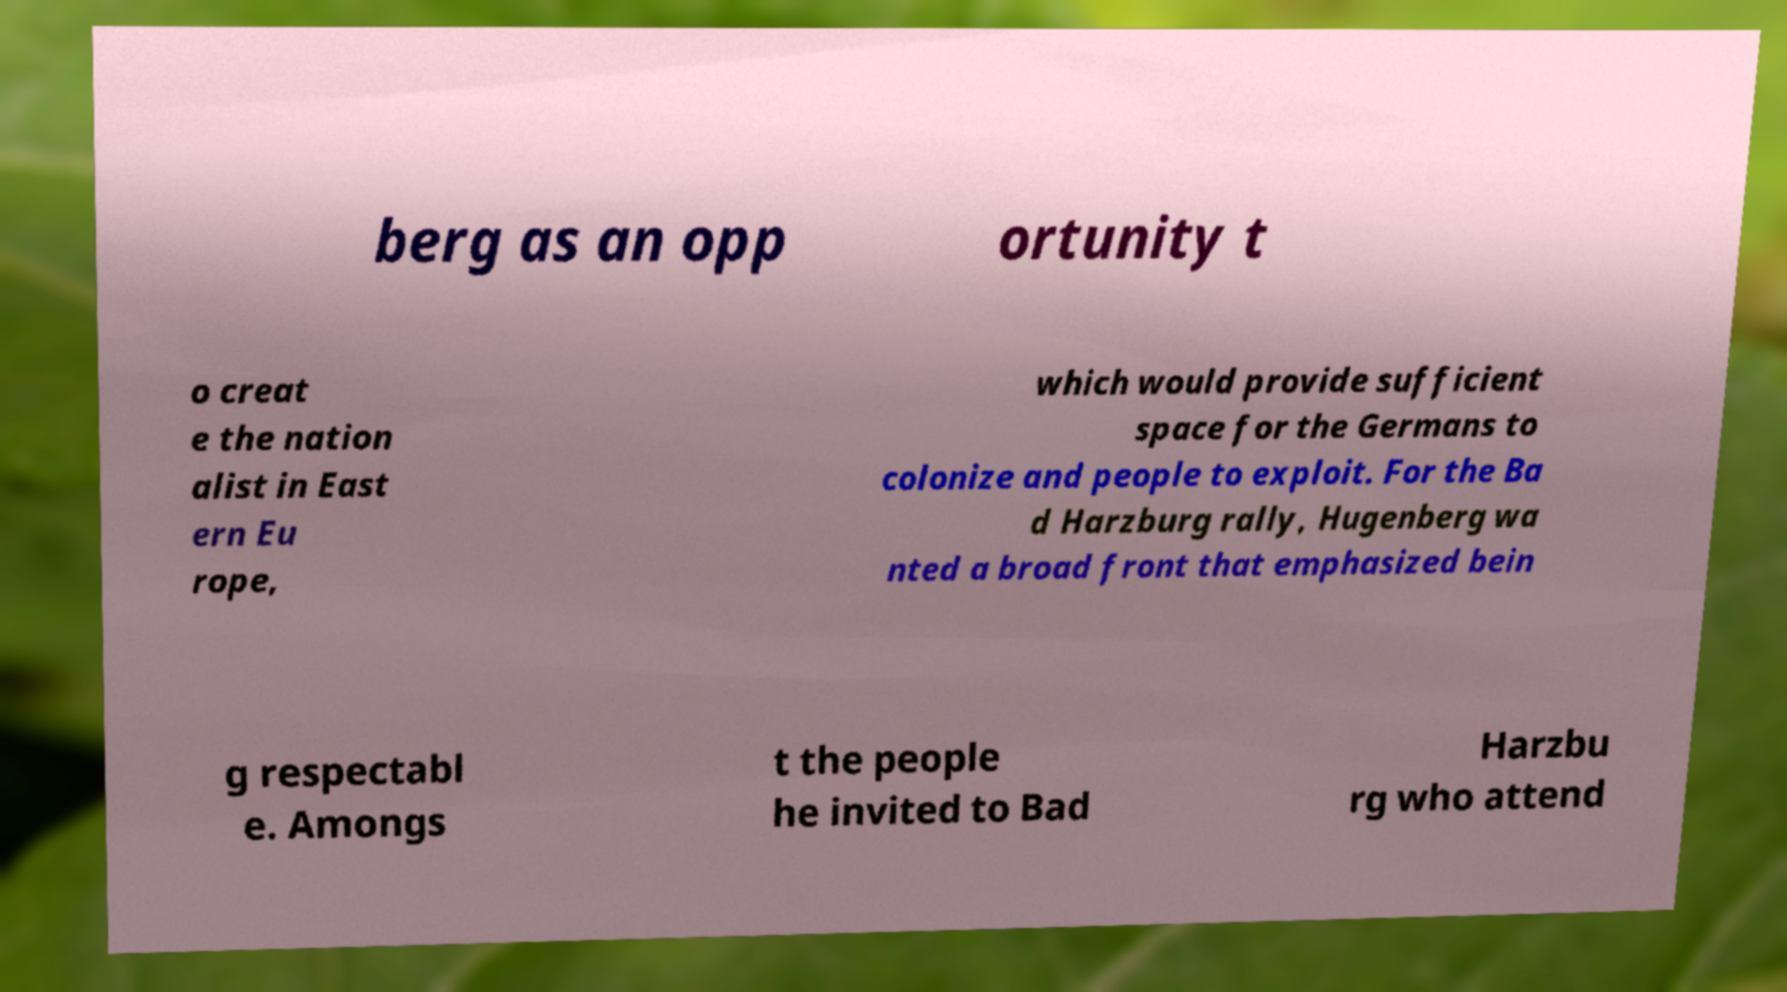Please read and relay the text visible in this image. What does it say? berg as an opp ortunity t o creat e the nation alist in East ern Eu rope, which would provide sufficient space for the Germans to colonize and people to exploit. For the Ba d Harzburg rally, Hugenberg wa nted a broad front that emphasized bein g respectabl e. Amongs t the people he invited to Bad Harzbu rg who attend 